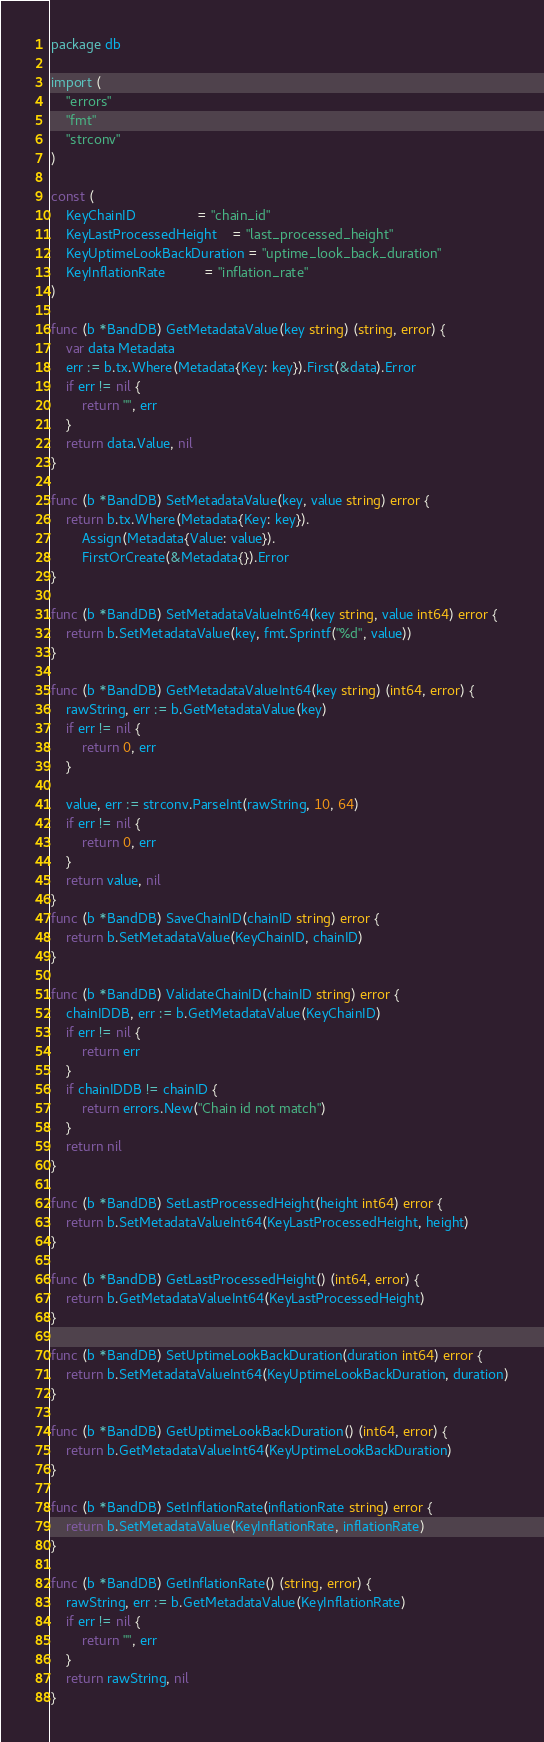<code> <loc_0><loc_0><loc_500><loc_500><_Go_>package db

import (
	"errors"
	"fmt"
	"strconv"
)

const (
	KeyChainID                = "chain_id"
	KeyLastProcessedHeight    = "last_processed_height"
	KeyUptimeLookBackDuration = "uptime_look_back_duration"
	KeyInflationRate          = "inflation_rate"
)

func (b *BandDB) GetMetadataValue(key string) (string, error) {
	var data Metadata
	err := b.tx.Where(Metadata{Key: key}).First(&data).Error
	if err != nil {
		return "", err
	}
	return data.Value, nil
}

func (b *BandDB) SetMetadataValue(key, value string) error {
	return b.tx.Where(Metadata{Key: key}).
		Assign(Metadata{Value: value}).
		FirstOrCreate(&Metadata{}).Error
}

func (b *BandDB) SetMetadataValueInt64(key string, value int64) error {
	return b.SetMetadataValue(key, fmt.Sprintf("%d", value))
}

func (b *BandDB) GetMetadataValueInt64(key string) (int64, error) {
	rawString, err := b.GetMetadataValue(key)
	if err != nil {
		return 0, err
	}

	value, err := strconv.ParseInt(rawString, 10, 64)
	if err != nil {
		return 0, err
	}
	return value, nil
}
func (b *BandDB) SaveChainID(chainID string) error {
	return b.SetMetadataValue(KeyChainID, chainID)
}

func (b *BandDB) ValidateChainID(chainID string) error {
	chainIDDB, err := b.GetMetadataValue(KeyChainID)
	if err != nil {
		return err
	}
	if chainIDDB != chainID {
		return errors.New("Chain id not match")
	}
	return nil
}

func (b *BandDB) SetLastProcessedHeight(height int64) error {
	return b.SetMetadataValueInt64(KeyLastProcessedHeight, height)
}

func (b *BandDB) GetLastProcessedHeight() (int64, error) {
	return b.GetMetadataValueInt64(KeyLastProcessedHeight)
}

func (b *BandDB) SetUptimeLookBackDuration(duration int64) error {
	return b.SetMetadataValueInt64(KeyUptimeLookBackDuration, duration)
}

func (b *BandDB) GetUptimeLookBackDuration() (int64, error) {
	return b.GetMetadataValueInt64(KeyUptimeLookBackDuration)
}

func (b *BandDB) SetInflationRate(inflationRate string) error {
	return b.SetMetadataValue(KeyInflationRate, inflationRate)
}

func (b *BandDB) GetInflationRate() (string, error) {
	rawString, err := b.GetMetadataValue(KeyInflationRate)
	if err != nil {
		return "", err
	}
	return rawString, nil
}
</code> 